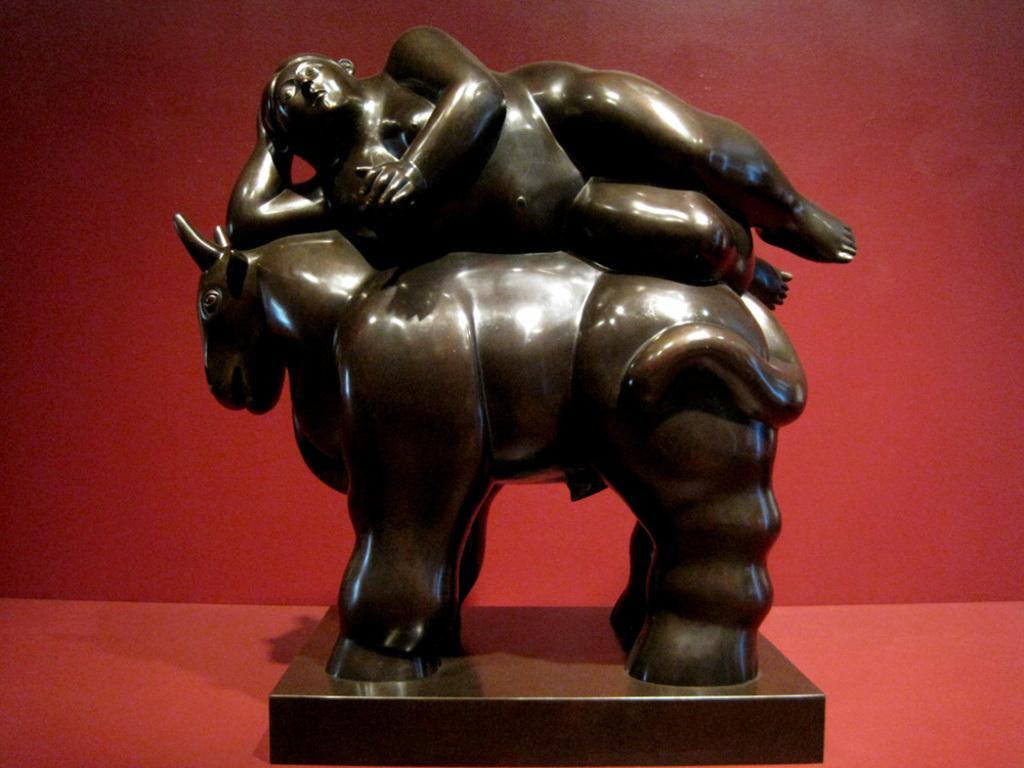What types of sculptures can be seen in the image? There is a sculpture of an animal and a sculpture of a human in the image. What is the color of the background in the image? The background of the image is in red color. What type of plants can be seen growing on the branch in the image? There is no branch or plants present in the image; it features two sculptures and a red background. 